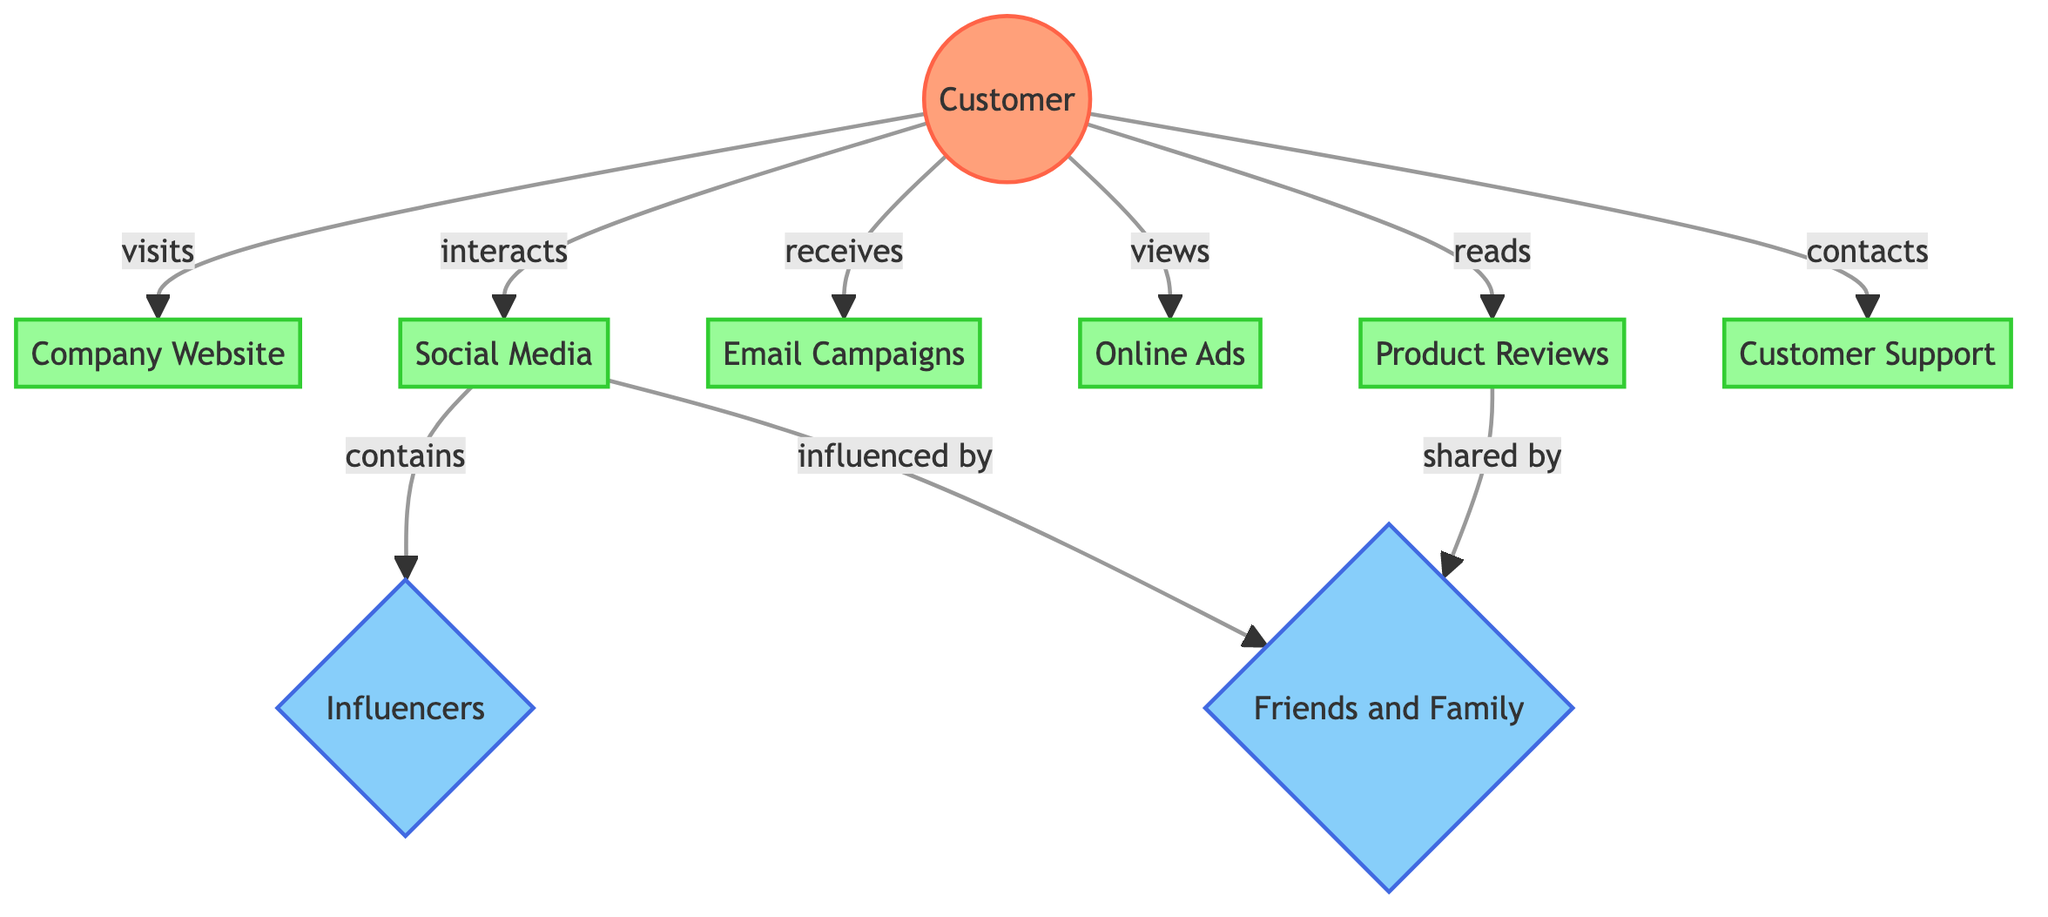What is the total number of nodes in the diagram? The diagram consists of nine nodes, which include Customer, Company Website, Social Media, Email Campaigns, Online Ads, Product Reviews, Customer Support, Influencers, and Friends and Family.
Answer: 9 What type of touchpoint is represented by Email Campaigns? Email Campaigns is categorized as a touchpoint, and its attributes indicate it serves as a means for marketing emails sent to customers.
Answer: touchpoint Which node is contacted by the Customer for support? The Customer reaches out to Customer Support for assistance, as indicated by the edge defining the relationship in the diagram.
Answer: Customer Support How does a Customer interact with Influencers? A Customer interacts with Influencers indirectly through Social Media, where they can follow and see content related to these Influencers.
Answer: Social Media What type of edges connect Customer to touchpoints? The edges connecting Customer to touchpoints include visits, interacts, receives, views, reads, and contacts. All these represent specific actions taken by the Customer towards these touchpoints.
Answer: visits, interacts, receives, views, reads, contacts How many influencers are present in the diagram? There are two influencers represented in the diagram: Influencers and Friends and Family, which are identified as distinct nodes affecting Customer decisions.
Answer: 2 What does the edge labeled "influenced by" indicate? The "influenced by" edge from Social Media to Friends and Family indicates that interactions on Social Media can impact customer decisions based on input from their personal network.
Answer: influenced by What are the primary interactions a Customer has with the Customer Support node? The primary interaction for the Customer with the Customer Support node is "contacts," reflecting the action taken by the Customer to seek help.
Answer: contacts How does Product Reviews relate to Friends and Family? Product Reviews shares an edge with Friends and Family labeled "shared by," indicating that reviews can be disseminated through personal connections.
Answer: shared by 